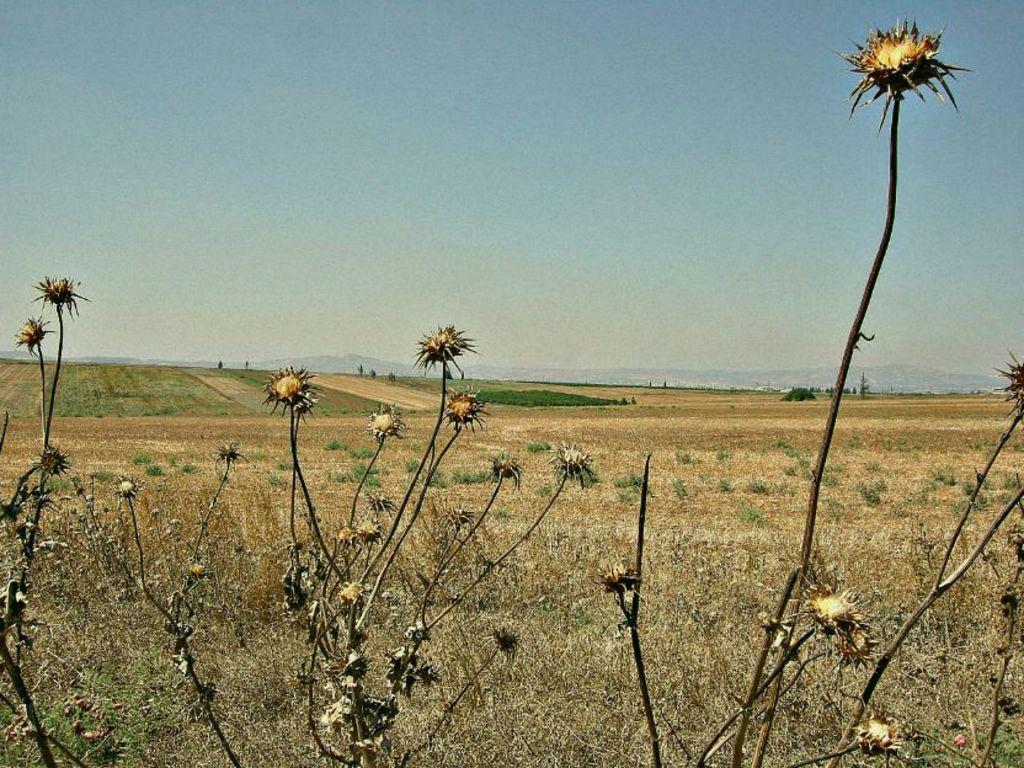How would you summarize this image in a sentence or two? In this picture we can see planets on the ground, grass and in the background we can see the sky. 